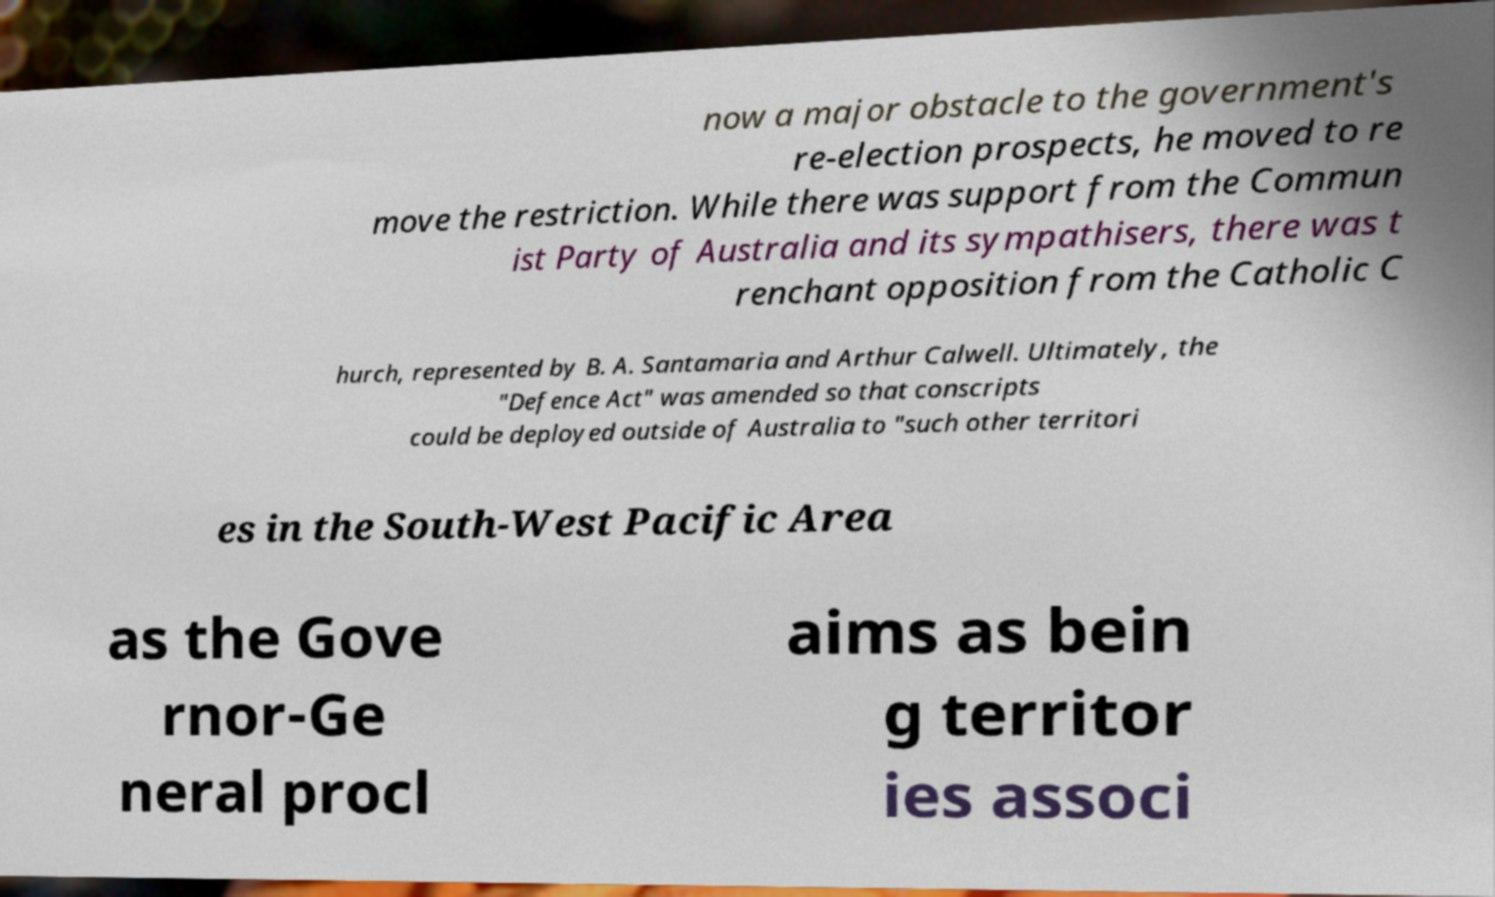There's text embedded in this image that I need extracted. Can you transcribe it verbatim? now a major obstacle to the government's re-election prospects, he moved to re move the restriction. While there was support from the Commun ist Party of Australia and its sympathisers, there was t renchant opposition from the Catholic C hurch, represented by B. A. Santamaria and Arthur Calwell. Ultimately, the "Defence Act" was amended so that conscripts could be deployed outside of Australia to "such other territori es in the South-West Pacific Area as the Gove rnor-Ge neral procl aims as bein g territor ies associ 